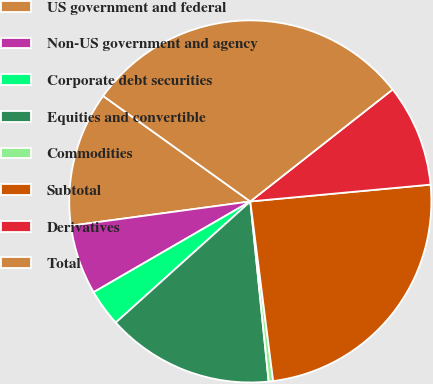<chart> <loc_0><loc_0><loc_500><loc_500><pie_chart><fcel>US government and federal<fcel>Non-US government and agency<fcel>Corporate debt securities<fcel>Equities and convertible<fcel>Commodities<fcel>Subtotal<fcel>Derivatives<fcel>Total<nl><fcel>12.04%<fcel>6.22%<fcel>3.31%<fcel>14.95%<fcel>0.4%<fcel>24.47%<fcel>9.13%<fcel>29.5%<nl></chart> 